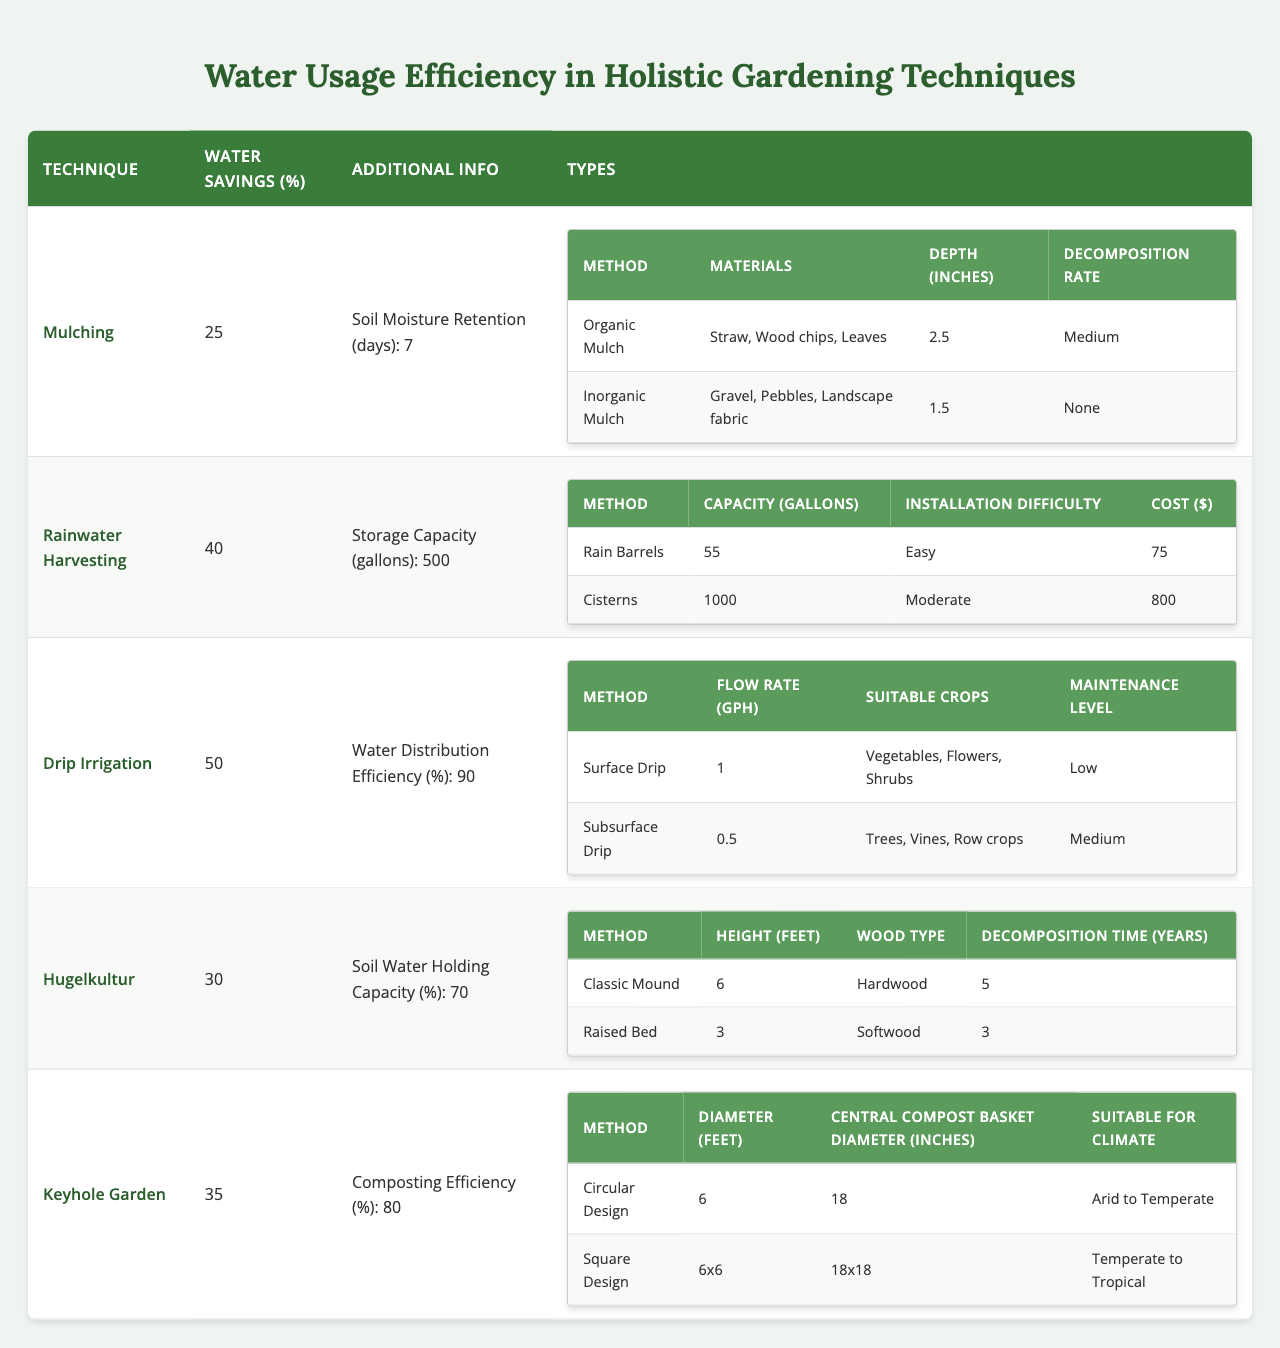What gardening technique offers the highest water savings percentage? Referring to the table, "Drip Irrigation" has the highest water savings percentage at 50%.
Answer: 50% How many days can mulching retain soil moisture? The table states that mulching retains soil moisture for 7 days.
Answer: 7 days What is the installation difficulty of cisterns in rainwater harvesting? The table indicates that the installation difficulty for cisterns is "Moderate."
Answer: Moderate Which type of mulch has a decomposition rate of "None"? The table shows that "Inorganic Mulch" has a decomposition rate of "None."
Answer: Inorganic Mulch How much water can a rain barrel store in gallons? The table specifies that a rain barrel has a capacity of 55 gallons.
Answer: 55 gallons What is the average water savings percentage for Hugelkultur and Keyhole Garden techniques? Hugelkultur saves 30% and Keyhole Garden saves 35%; the average is (30 + 35) / 2 = 32.5%.
Answer: 32.5% Is drip irrigation more efficient than rainwater harvesting in terms of water distribution efficiency? Yes, drip irrigation has a water distribution efficiency of 90%, while rainwater harvesting does not provide this specific metric.
Answer: Yes What water savings percentage is associated with the Keyhole Garden technique? The table reveals that the Keyhole Garden technique has a water savings percentage of 35%.
Answer: 35% Which method in the Hugelkultur technique has a longer decomposition time? The "Classic Mound" method has a decomposition time of 5 years, while "Raised Bed" has 3 years, indicating Classic Mound has a longer duration.
Answer: Classic Mound If you combine the water savings from mulching and hugelkultur, what is the total water savings percentage? Mulching saves 25% and Hugelkultur saves 30%; thus, the combined savings is 25 + 30 = 55%.
Answer: 55% 